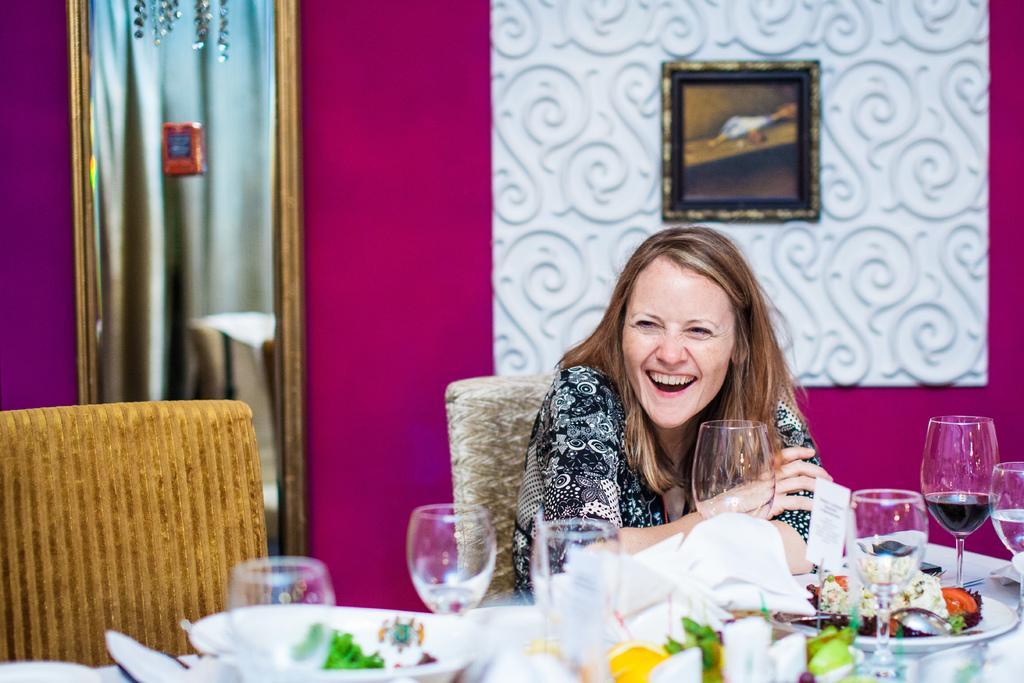Describe this image in one or two sentences. In this image we can see a woman sitting on the chair near the table. We can see glasses and plates with food on the table. In the background we can see a photo frame on the wall. 